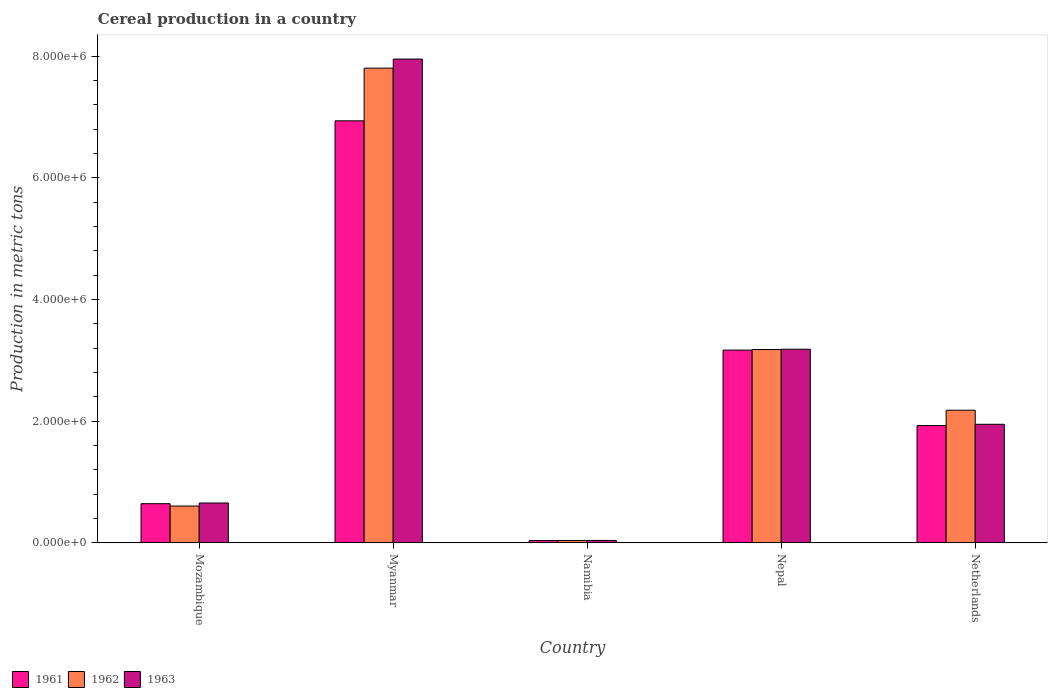How many different coloured bars are there?
Keep it short and to the point. 3. How many bars are there on the 5th tick from the left?
Ensure brevity in your answer.  3. How many bars are there on the 4th tick from the right?
Provide a succinct answer. 3. What is the label of the 1st group of bars from the left?
Your answer should be compact. Mozambique. In how many cases, is the number of bars for a given country not equal to the number of legend labels?
Keep it short and to the point. 0. What is the total cereal production in 1962 in Namibia?
Your response must be concise. 3.71e+04. Across all countries, what is the maximum total cereal production in 1963?
Offer a terse response. 7.95e+06. Across all countries, what is the minimum total cereal production in 1962?
Provide a succinct answer. 3.71e+04. In which country was the total cereal production in 1961 maximum?
Provide a short and direct response. Myanmar. In which country was the total cereal production in 1962 minimum?
Your answer should be compact. Namibia. What is the total total cereal production in 1963 in the graph?
Provide a short and direct response. 1.38e+07. What is the difference between the total cereal production in 1963 in Mozambique and that in Myanmar?
Ensure brevity in your answer.  -7.30e+06. What is the difference between the total cereal production in 1963 in Myanmar and the total cereal production in 1961 in Nepal?
Make the answer very short. 4.79e+06. What is the average total cereal production in 1961 per country?
Make the answer very short. 2.54e+06. What is the difference between the total cereal production of/in 1961 and total cereal production of/in 1962 in Namibia?
Make the answer very short. -1476. In how many countries, is the total cereal production in 1963 greater than 4000000 metric tons?
Your answer should be compact. 1. What is the ratio of the total cereal production in 1962 in Mozambique to that in Nepal?
Ensure brevity in your answer.  0.19. Is the total cereal production in 1961 in Nepal less than that in Netherlands?
Your response must be concise. No. Is the difference between the total cereal production in 1961 in Namibia and Nepal greater than the difference between the total cereal production in 1962 in Namibia and Nepal?
Provide a succinct answer. Yes. What is the difference between the highest and the second highest total cereal production in 1962?
Give a very brief answer. -9.99e+05. What is the difference between the highest and the lowest total cereal production in 1963?
Your response must be concise. 7.92e+06. What does the 1st bar from the left in Nepal represents?
Your answer should be compact. 1961. How many countries are there in the graph?
Offer a very short reply. 5. Are the values on the major ticks of Y-axis written in scientific E-notation?
Offer a terse response. Yes. Where does the legend appear in the graph?
Provide a short and direct response. Bottom left. How are the legend labels stacked?
Your response must be concise. Horizontal. What is the title of the graph?
Your answer should be compact. Cereal production in a country. Does "1979" appear as one of the legend labels in the graph?
Your answer should be compact. No. What is the label or title of the X-axis?
Your answer should be very brief. Country. What is the label or title of the Y-axis?
Your answer should be compact. Production in metric tons. What is the Production in metric tons of 1961 in Mozambique?
Make the answer very short. 6.42e+05. What is the Production in metric tons of 1962 in Mozambique?
Your answer should be compact. 6.03e+05. What is the Production in metric tons in 1963 in Mozambique?
Your answer should be very brief. 6.53e+05. What is the Production in metric tons of 1961 in Myanmar?
Provide a short and direct response. 6.94e+06. What is the Production in metric tons in 1962 in Myanmar?
Your answer should be very brief. 7.80e+06. What is the Production in metric tons in 1963 in Myanmar?
Make the answer very short. 7.95e+06. What is the Production in metric tons in 1961 in Namibia?
Make the answer very short. 3.56e+04. What is the Production in metric tons of 1962 in Namibia?
Make the answer very short. 3.71e+04. What is the Production in metric tons in 1963 in Namibia?
Offer a very short reply. 3.72e+04. What is the Production in metric tons in 1961 in Nepal?
Ensure brevity in your answer.  3.17e+06. What is the Production in metric tons in 1962 in Nepal?
Give a very brief answer. 3.18e+06. What is the Production in metric tons of 1963 in Nepal?
Your response must be concise. 3.18e+06. What is the Production in metric tons in 1961 in Netherlands?
Ensure brevity in your answer.  1.93e+06. What is the Production in metric tons in 1962 in Netherlands?
Offer a terse response. 2.18e+06. What is the Production in metric tons in 1963 in Netherlands?
Offer a terse response. 1.95e+06. Across all countries, what is the maximum Production in metric tons of 1961?
Provide a succinct answer. 6.94e+06. Across all countries, what is the maximum Production in metric tons in 1962?
Keep it short and to the point. 7.80e+06. Across all countries, what is the maximum Production in metric tons of 1963?
Your response must be concise. 7.95e+06. Across all countries, what is the minimum Production in metric tons in 1961?
Ensure brevity in your answer.  3.56e+04. Across all countries, what is the minimum Production in metric tons of 1962?
Make the answer very short. 3.71e+04. Across all countries, what is the minimum Production in metric tons of 1963?
Provide a succinct answer. 3.72e+04. What is the total Production in metric tons of 1961 in the graph?
Keep it short and to the point. 1.27e+07. What is the total Production in metric tons in 1962 in the graph?
Keep it short and to the point. 1.38e+07. What is the total Production in metric tons in 1963 in the graph?
Ensure brevity in your answer.  1.38e+07. What is the difference between the Production in metric tons of 1961 in Mozambique and that in Myanmar?
Offer a very short reply. -6.30e+06. What is the difference between the Production in metric tons in 1962 in Mozambique and that in Myanmar?
Keep it short and to the point. -7.20e+06. What is the difference between the Production in metric tons of 1963 in Mozambique and that in Myanmar?
Give a very brief answer. -7.30e+06. What is the difference between the Production in metric tons in 1961 in Mozambique and that in Namibia?
Your answer should be very brief. 6.06e+05. What is the difference between the Production in metric tons in 1962 in Mozambique and that in Namibia?
Provide a succinct answer. 5.66e+05. What is the difference between the Production in metric tons in 1963 in Mozambique and that in Namibia?
Your response must be concise. 6.16e+05. What is the difference between the Production in metric tons in 1961 in Mozambique and that in Nepal?
Offer a very short reply. -2.53e+06. What is the difference between the Production in metric tons of 1962 in Mozambique and that in Nepal?
Keep it short and to the point. -2.57e+06. What is the difference between the Production in metric tons of 1963 in Mozambique and that in Nepal?
Offer a terse response. -2.53e+06. What is the difference between the Production in metric tons in 1961 in Mozambique and that in Netherlands?
Your answer should be very brief. -1.28e+06. What is the difference between the Production in metric tons of 1962 in Mozambique and that in Netherlands?
Provide a short and direct response. -1.58e+06. What is the difference between the Production in metric tons in 1963 in Mozambique and that in Netherlands?
Offer a terse response. -1.29e+06. What is the difference between the Production in metric tons in 1961 in Myanmar and that in Namibia?
Keep it short and to the point. 6.90e+06. What is the difference between the Production in metric tons in 1962 in Myanmar and that in Namibia?
Offer a terse response. 7.77e+06. What is the difference between the Production in metric tons in 1963 in Myanmar and that in Namibia?
Keep it short and to the point. 7.92e+06. What is the difference between the Production in metric tons of 1961 in Myanmar and that in Nepal?
Keep it short and to the point. 3.77e+06. What is the difference between the Production in metric tons of 1962 in Myanmar and that in Nepal?
Your answer should be very brief. 4.63e+06. What is the difference between the Production in metric tons of 1963 in Myanmar and that in Nepal?
Your response must be concise. 4.77e+06. What is the difference between the Production in metric tons of 1961 in Myanmar and that in Netherlands?
Give a very brief answer. 5.01e+06. What is the difference between the Production in metric tons of 1962 in Myanmar and that in Netherlands?
Make the answer very short. 5.62e+06. What is the difference between the Production in metric tons in 1963 in Myanmar and that in Netherlands?
Keep it short and to the point. 6.01e+06. What is the difference between the Production in metric tons of 1961 in Namibia and that in Nepal?
Make the answer very short. -3.13e+06. What is the difference between the Production in metric tons of 1962 in Namibia and that in Nepal?
Provide a short and direct response. -3.14e+06. What is the difference between the Production in metric tons of 1963 in Namibia and that in Nepal?
Provide a succinct answer. -3.14e+06. What is the difference between the Production in metric tons in 1961 in Namibia and that in Netherlands?
Provide a succinct answer. -1.89e+06. What is the difference between the Production in metric tons in 1962 in Namibia and that in Netherlands?
Provide a short and direct response. -2.14e+06. What is the difference between the Production in metric tons in 1963 in Namibia and that in Netherlands?
Provide a succinct answer. -1.91e+06. What is the difference between the Production in metric tons in 1961 in Nepal and that in Netherlands?
Provide a succinct answer. 1.24e+06. What is the difference between the Production in metric tons in 1962 in Nepal and that in Netherlands?
Make the answer very short. 9.99e+05. What is the difference between the Production in metric tons in 1963 in Nepal and that in Netherlands?
Provide a succinct answer. 1.23e+06. What is the difference between the Production in metric tons of 1961 in Mozambique and the Production in metric tons of 1962 in Myanmar?
Your response must be concise. -7.16e+06. What is the difference between the Production in metric tons of 1961 in Mozambique and the Production in metric tons of 1963 in Myanmar?
Make the answer very short. -7.31e+06. What is the difference between the Production in metric tons in 1962 in Mozambique and the Production in metric tons in 1963 in Myanmar?
Offer a terse response. -7.35e+06. What is the difference between the Production in metric tons in 1961 in Mozambique and the Production in metric tons in 1962 in Namibia?
Offer a terse response. 6.05e+05. What is the difference between the Production in metric tons in 1961 in Mozambique and the Production in metric tons in 1963 in Namibia?
Your response must be concise. 6.05e+05. What is the difference between the Production in metric tons in 1962 in Mozambique and the Production in metric tons in 1963 in Namibia?
Provide a short and direct response. 5.66e+05. What is the difference between the Production in metric tons in 1961 in Mozambique and the Production in metric tons in 1962 in Nepal?
Offer a terse response. -2.54e+06. What is the difference between the Production in metric tons of 1961 in Mozambique and the Production in metric tons of 1963 in Nepal?
Give a very brief answer. -2.54e+06. What is the difference between the Production in metric tons in 1962 in Mozambique and the Production in metric tons in 1963 in Nepal?
Ensure brevity in your answer.  -2.58e+06. What is the difference between the Production in metric tons in 1961 in Mozambique and the Production in metric tons in 1962 in Netherlands?
Offer a terse response. -1.54e+06. What is the difference between the Production in metric tons of 1961 in Mozambique and the Production in metric tons of 1963 in Netherlands?
Keep it short and to the point. -1.31e+06. What is the difference between the Production in metric tons of 1962 in Mozambique and the Production in metric tons of 1963 in Netherlands?
Make the answer very short. -1.34e+06. What is the difference between the Production in metric tons of 1961 in Myanmar and the Production in metric tons of 1962 in Namibia?
Your response must be concise. 6.90e+06. What is the difference between the Production in metric tons of 1961 in Myanmar and the Production in metric tons of 1963 in Namibia?
Provide a short and direct response. 6.90e+06. What is the difference between the Production in metric tons in 1962 in Myanmar and the Production in metric tons in 1963 in Namibia?
Give a very brief answer. 7.77e+06. What is the difference between the Production in metric tons of 1961 in Myanmar and the Production in metric tons of 1962 in Nepal?
Keep it short and to the point. 3.76e+06. What is the difference between the Production in metric tons in 1961 in Myanmar and the Production in metric tons in 1963 in Nepal?
Provide a short and direct response. 3.76e+06. What is the difference between the Production in metric tons in 1962 in Myanmar and the Production in metric tons in 1963 in Nepal?
Offer a very short reply. 4.62e+06. What is the difference between the Production in metric tons of 1961 in Myanmar and the Production in metric tons of 1962 in Netherlands?
Provide a short and direct response. 4.76e+06. What is the difference between the Production in metric tons of 1961 in Myanmar and the Production in metric tons of 1963 in Netherlands?
Make the answer very short. 4.99e+06. What is the difference between the Production in metric tons in 1962 in Myanmar and the Production in metric tons in 1963 in Netherlands?
Make the answer very short. 5.86e+06. What is the difference between the Production in metric tons of 1961 in Namibia and the Production in metric tons of 1962 in Nepal?
Provide a succinct answer. -3.14e+06. What is the difference between the Production in metric tons of 1961 in Namibia and the Production in metric tons of 1963 in Nepal?
Provide a short and direct response. -3.15e+06. What is the difference between the Production in metric tons of 1962 in Namibia and the Production in metric tons of 1963 in Nepal?
Provide a short and direct response. -3.14e+06. What is the difference between the Production in metric tons of 1961 in Namibia and the Production in metric tons of 1962 in Netherlands?
Keep it short and to the point. -2.14e+06. What is the difference between the Production in metric tons in 1961 in Namibia and the Production in metric tons in 1963 in Netherlands?
Provide a short and direct response. -1.91e+06. What is the difference between the Production in metric tons in 1962 in Namibia and the Production in metric tons in 1963 in Netherlands?
Provide a short and direct response. -1.91e+06. What is the difference between the Production in metric tons in 1961 in Nepal and the Production in metric tons in 1962 in Netherlands?
Ensure brevity in your answer.  9.89e+05. What is the difference between the Production in metric tons of 1961 in Nepal and the Production in metric tons of 1963 in Netherlands?
Your answer should be very brief. 1.22e+06. What is the difference between the Production in metric tons of 1962 in Nepal and the Production in metric tons of 1963 in Netherlands?
Keep it short and to the point. 1.23e+06. What is the average Production in metric tons in 1961 per country?
Your response must be concise. 2.54e+06. What is the average Production in metric tons of 1962 per country?
Keep it short and to the point. 2.76e+06. What is the average Production in metric tons of 1963 per country?
Your response must be concise. 2.75e+06. What is the difference between the Production in metric tons in 1961 and Production in metric tons in 1962 in Mozambique?
Make the answer very short. 3.88e+04. What is the difference between the Production in metric tons of 1961 and Production in metric tons of 1963 in Mozambique?
Offer a very short reply. -1.12e+04. What is the difference between the Production in metric tons of 1961 and Production in metric tons of 1962 in Myanmar?
Make the answer very short. -8.66e+05. What is the difference between the Production in metric tons of 1961 and Production in metric tons of 1963 in Myanmar?
Ensure brevity in your answer.  -1.02e+06. What is the difference between the Production in metric tons in 1962 and Production in metric tons in 1963 in Myanmar?
Your response must be concise. -1.49e+05. What is the difference between the Production in metric tons in 1961 and Production in metric tons in 1962 in Namibia?
Keep it short and to the point. -1476. What is the difference between the Production in metric tons of 1961 and Production in metric tons of 1963 in Namibia?
Your answer should be compact. -1616. What is the difference between the Production in metric tons in 1962 and Production in metric tons in 1963 in Namibia?
Make the answer very short. -140. What is the difference between the Production in metric tons in 1961 and Production in metric tons in 1962 in Nepal?
Ensure brevity in your answer.  -1.00e+04. What is the difference between the Production in metric tons in 1961 and Production in metric tons in 1963 in Nepal?
Your response must be concise. -1.46e+04. What is the difference between the Production in metric tons of 1962 and Production in metric tons of 1963 in Nepal?
Keep it short and to the point. -4552. What is the difference between the Production in metric tons of 1961 and Production in metric tons of 1962 in Netherlands?
Ensure brevity in your answer.  -2.52e+05. What is the difference between the Production in metric tons in 1961 and Production in metric tons in 1963 in Netherlands?
Offer a terse response. -2.11e+04. What is the difference between the Production in metric tons in 1962 and Production in metric tons in 1963 in Netherlands?
Your response must be concise. 2.31e+05. What is the ratio of the Production in metric tons in 1961 in Mozambique to that in Myanmar?
Offer a terse response. 0.09. What is the ratio of the Production in metric tons of 1962 in Mozambique to that in Myanmar?
Your answer should be very brief. 0.08. What is the ratio of the Production in metric tons of 1963 in Mozambique to that in Myanmar?
Offer a very short reply. 0.08. What is the ratio of the Production in metric tons of 1961 in Mozambique to that in Namibia?
Your response must be concise. 18.03. What is the ratio of the Production in metric tons in 1962 in Mozambique to that in Namibia?
Make the answer very short. 16.27. What is the ratio of the Production in metric tons in 1963 in Mozambique to that in Namibia?
Provide a succinct answer. 17.55. What is the ratio of the Production in metric tons of 1961 in Mozambique to that in Nepal?
Provide a short and direct response. 0.2. What is the ratio of the Production in metric tons in 1962 in Mozambique to that in Nepal?
Offer a terse response. 0.19. What is the ratio of the Production in metric tons of 1963 in Mozambique to that in Nepal?
Your response must be concise. 0.21. What is the ratio of the Production in metric tons of 1961 in Mozambique to that in Netherlands?
Offer a terse response. 0.33. What is the ratio of the Production in metric tons in 1962 in Mozambique to that in Netherlands?
Provide a short and direct response. 0.28. What is the ratio of the Production in metric tons of 1963 in Mozambique to that in Netherlands?
Keep it short and to the point. 0.34. What is the ratio of the Production in metric tons of 1961 in Myanmar to that in Namibia?
Ensure brevity in your answer.  194.9. What is the ratio of the Production in metric tons in 1962 in Myanmar to that in Namibia?
Give a very brief answer. 210.51. What is the ratio of the Production in metric tons of 1963 in Myanmar to that in Namibia?
Make the answer very short. 213.73. What is the ratio of the Production in metric tons in 1961 in Myanmar to that in Nepal?
Offer a terse response. 2.19. What is the ratio of the Production in metric tons in 1962 in Myanmar to that in Nepal?
Make the answer very short. 2.46. What is the ratio of the Production in metric tons of 1963 in Myanmar to that in Nepal?
Offer a terse response. 2.5. What is the ratio of the Production in metric tons in 1961 in Myanmar to that in Netherlands?
Provide a succinct answer. 3.6. What is the ratio of the Production in metric tons in 1962 in Myanmar to that in Netherlands?
Make the answer very short. 3.58. What is the ratio of the Production in metric tons in 1963 in Myanmar to that in Netherlands?
Your answer should be very brief. 4.08. What is the ratio of the Production in metric tons in 1961 in Namibia to that in Nepal?
Give a very brief answer. 0.01. What is the ratio of the Production in metric tons in 1962 in Namibia to that in Nepal?
Your response must be concise. 0.01. What is the ratio of the Production in metric tons in 1963 in Namibia to that in Nepal?
Make the answer very short. 0.01. What is the ratio of the Production in metric tons in 1961 in Namibia to that in Netherlands?
Your response must be concise. 0.02. What is the ratio of the Production in metric tons in 1962 in Namibia to that in Netherlands?
Offer a very short reply. 0.02. What is the ratio of the Production in metric tons of 1963 in Namibia to that in Netherlands?
Your answer should be very brief. 0.02. What is the ratio of the Production in metric tons in 1961 in Nepal to that in Netherlands?
Your answer should be compact. 1.64. What is the ratio of the Production in metric tons in 1962 in Nepal to that in Netherlands?
Your answer should be compact. 1.46. What is the ratio of the Production in metric tons in 1963 in Nepal to that in Netherlands?
Ensure brevity in your answer.  1.63. What is the difference between the highest and the second highest Production in metric tons of 1961?
Keep it short and to the point. 3.77e+06. What is the difference between the highest and the second highest Production in metric tons of 1962?
Your answer should be very brief. 4.63e+06. What is the difference between the highest and the second highest Production in metric tons of 1963?
Provide a succinct answer. 4.77e+06. What is the difference between the highest and the lowest Production in metric tons in 1961?
Your response must be concise. 6.90e+06. What is the difference between the highest and the lowest Production in metric tons in 1962?
Make the answer very short. 7.77e+06. What is the difference between the highest and the lowest Production in metric tons of 1963?
Make the answer very short. 7.92e+06. 